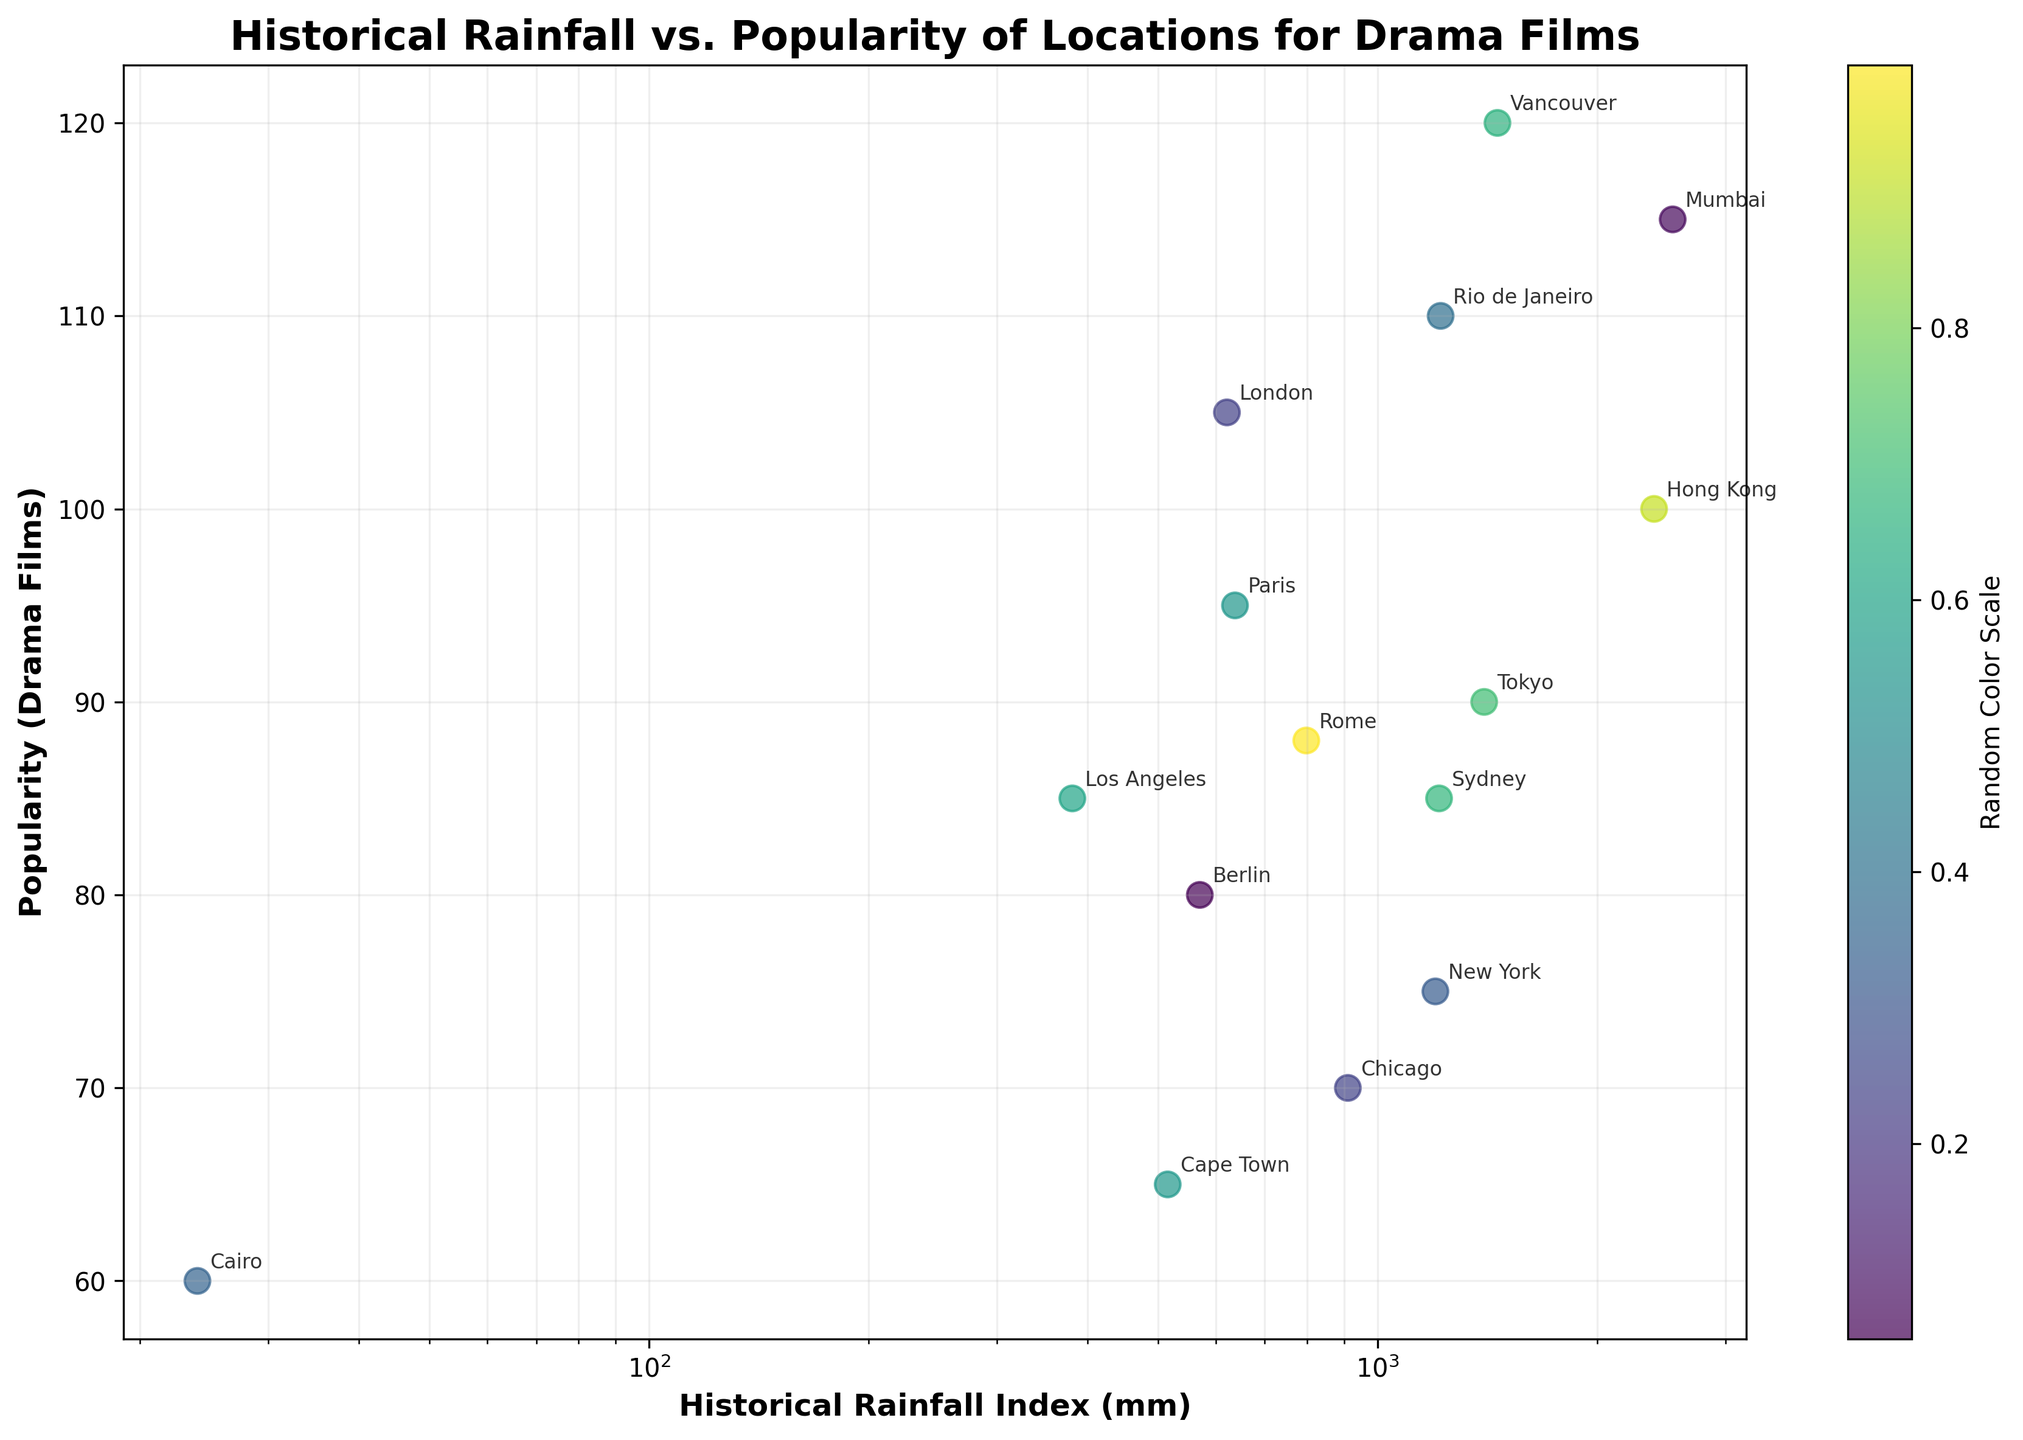What's the title of the figure? The title is displayed at the top of the figure and it reads, "Historical Rainfall vs. Popularity of Locations for Drama Films".
Answer: Historical Rainfall vs. Popularity of Locations for Drama Films On which axis is the Historical Rainfall Index plotted? The Historical Rainfall Index is plotted on the x-axis, which is explicitly labeled as "Historical Rainfall Index (mm)".
Answer: x-axis What color scale is used for the scatter plot? A color scale with the label "Random Color Scale" is shown with a color gradient from the viridis colormap, which is visible to the right of the scatter plot.
Answer: Viridis How many locations have a Historical Rainfall Index of over 1000 mm? By examining the plot and identifying the points on the x-axis with values over 1000 mm, we can count Los Angeles, Mumbai, Tokyo, Vancouver, and Rio de Janeiro.
Answer: 5 Which location has the highest popularity for drama films? The location with the highest value on the y-axis, which is Vancouver with a popularity score of 120, represents the highest popularity for drama films.
Answer: Vancouver What is the approximate popularity of New York? By locating the point for New York and tracing it to the y-axis, we find that New York has an approximate popularity of 75.
Answer: 75 Compare the Historical Rainfall Index of Tokyo and London. Which one is higher and by how much? Tokyo's index is approximately 1400 mm, while London's is around 621 mm. The difference is 1400 - 621 = 779 mm, making Tokyo's index higher.
Answer: Tokyo by 779 mm What is the relationship between the historical rainfall index and the popularity of locations for drama films? By analyzing the scatter plot, there does not seem to be a clear linear relationship between historical rainfall index and popularity of the locations as the points are spread out in a dispersed pattern.
Answer: No clear relationship What's the average popularity score of locations with a Historical Rainfall Index under 500 mm? The locations with rainfall under 500 mm are Los Angeles (85), Cairo (60), Cape Town (65). Hence, the average is (85 + 60 + 65) / 3 = 70.
Answer: 70 How does the popularity of locations in New York compare to Sydney? New York’s popularity is approximately 75, while Sydney’s is about 85. Hence, Sydney is more popular compared to New York.
Answer: Sydney is more popular 